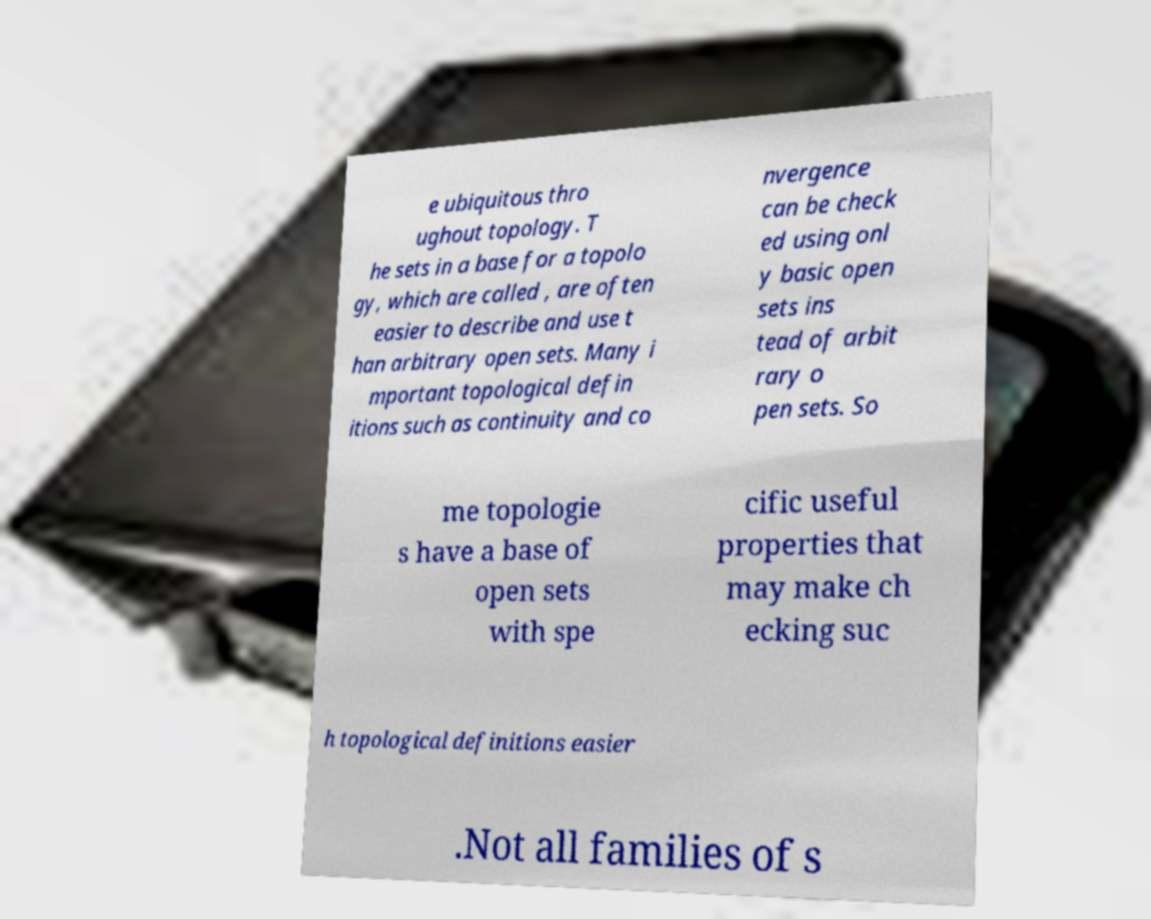What messages or text are displayed in this image? I need them in a readable, typed format. e ubiquitous thro ughout topology. T he sets in a base for a topolo gy, which are called , are often easier to describe and use t han arbitrary open sets. Many i mportant topological defin itions such as continuity and co nvergence can be check ed using onl y basic open sets ins tead of arbit rary o pen sets. So me topologie s have a base of open sets with spe cific useful properties that may make ch ecking suc h topological definitions easier .Not all families of s 